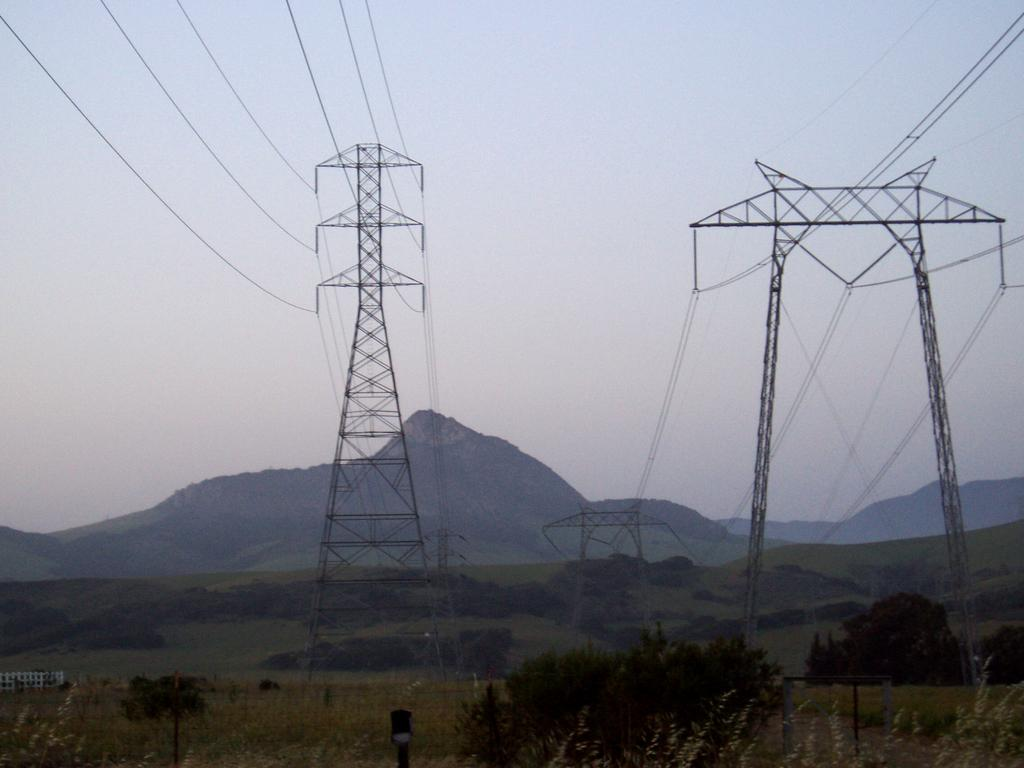What type of natural elements can be seen in the image? There are trees in the image. What man-made structures are present in the image? There are power towers in the image. What can be seen in the distance in the image? There are mountains visible in the background of the image. What is visible in the sky in the image? The sky is visible in the background of the image. Where is the sand located in the image? There is no sand present in the image. What type of machine can be seen operating in the image? There is no machine present in the image. 